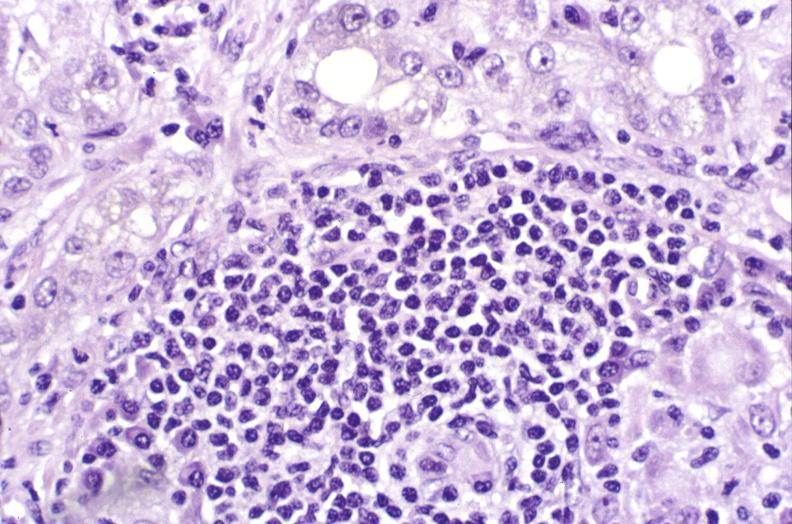does appendix show primary biliary cirrhosis?
Answer the question using a single word or phrase. No 